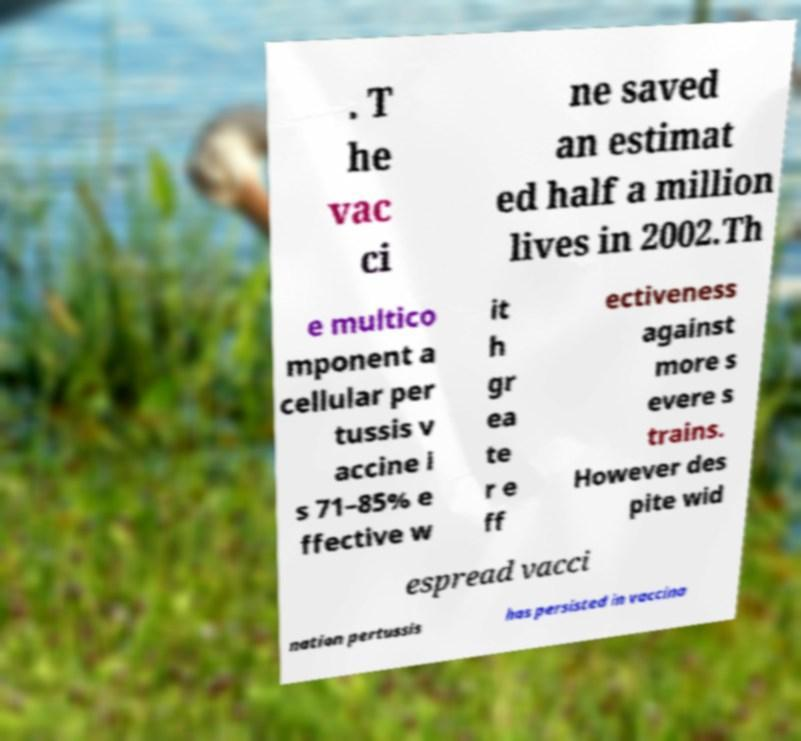Could you assist in decoding the text presented in this image and type it out clearly? . T he vac ci ne saved an estimat ed half a million lives in 2002.Th e multico mponent a cellular per tussis v accine i s 71–85% e ffective w it h gr ea te r e ff ectiveness against more s evere s trains. However des pite wid espread vacci nation pertussis has persisted in vaccina 